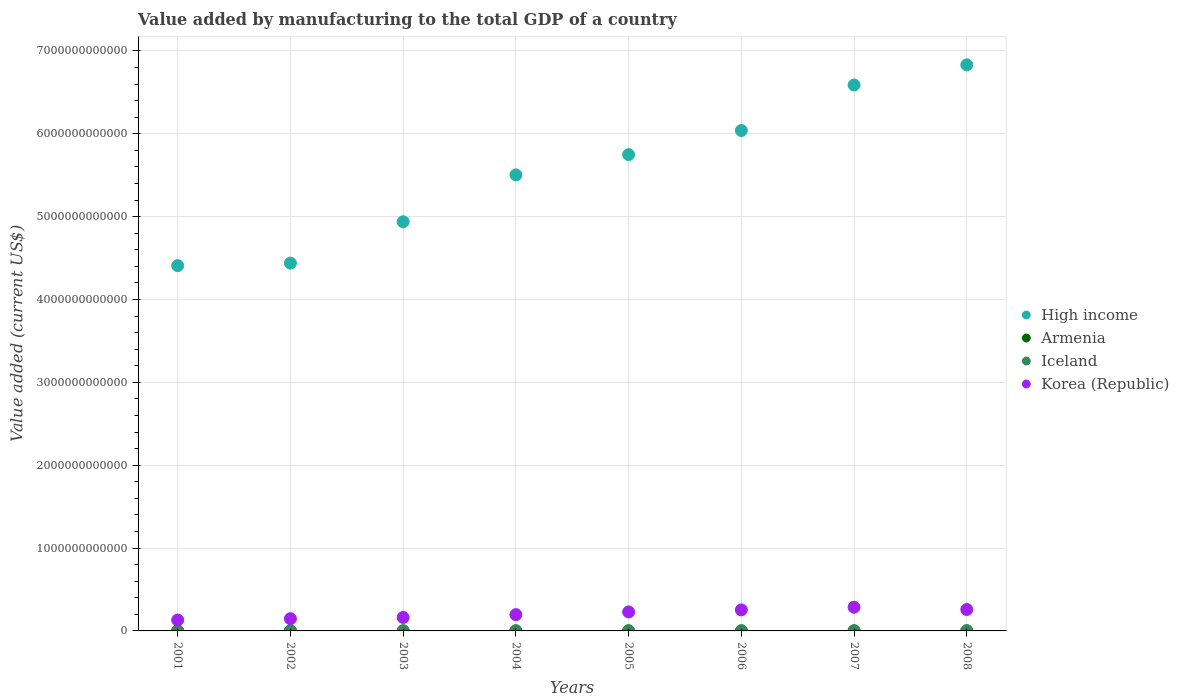How many different coloured dotlines are there?
Provide a succinct answer. 4. What is the value added by manufacturing to the total GDP in High income in 2005?
Provide a succinct answer. 5.75e+12. Across all years, what is the maximum value added by manufacturing to the total GDP in Iceland?
Offer a very short reply. 1.92e+09. Across all years, what is the minimum value added by manufacturing to the total GDP in Armenia?
Provide a succinct answer. 3.32e+08. In which year was the value added by manufacturing to the total GDP in High income maximum?
Offer a terse response. 2008. What is the total value added by manufacturing to the total GDP in High income in the graph?
Your answer should be compact. 4.45e+13. What is the difference between the value added by manufacturing to the total GDP in Armenia in 2004 and that in 2005?
Provide a short and direct response. -1.79e+08. What is the difference between the value added by manufacturing to the total GDP in Iceland in 2002 and the value added by manufacturing to the total GDP in Korea (Republic) in 2008?
Your response must be concise. -2.57e+11. What is the average value added by manufacturing to the total GDP in Korea (Republic) per year?
Provide a short and direct response. 2.08e+11. In the year 2008, what is the difference between the value added by manufacturing to the total GDP in Iceland and value added by manufacturing to the total GDP in Armenia?
Make the answer very short. 8.91e+08. What is the ratio of the value added by manufacturing to the total GDP in Iceland in 2003 to that in 2006?
Offer a very short reply. 0.8. Is the value added by manufacturing to the total GDP in Armenia in 2006 less than that in 2007?
Keep it short and to the point. Yes. Is the difference between the value added by manufacturing to the total GDP in Iceland in 2004 and 2008 greater than the difference between the value added by manufacturing to the total GDP in Armenia in 2004 and 2008?
Your answer should be compact. Yes. What is the difference between the highest and the second highest value added by manufacturing to the total GDP in Korea (Republic)?
Give a very brief answer. 2.73e+1. What is the difference between the highest and the lowest value added by manufacturing to the total GDP in Iceland?
Offer a very short reply. 8.62e+08. In how many years, is the value added by manufacturing to the total GDP in Armenia greater than the average value added by manufacturing to the total GDP in Armenia taken over all years?
Your answer should be compact. 4. Is the sum of the value added by manufacturing to the total GDP in Korea (Republic) in 2002 and 2006 greater than the maximum value added by manufacturing to the total GDP in Armenia across all years?
Your response must be concise. Yes. Is it the case that in every year, the sum of the value added by manufacturing to the total GDP in Armenia and value added by manufacturing to the total GDP in Korea (Republic)  is greater than the sum of value added by manufacturing to the total GDP in Iceland and value added by manufacturing to the total GDP in High income?
Give a very brief answer. Yes. Does the value added by manufacturing to the total GDP in Iceland monotonically increase over the years?
Ensure brevity in your answer.  No. What is the difference between two consecutive major ticks on the Y-axis?
Provide a short and direct response. 1.00e+12. Are the values on the major ticks of Y-axis written in scientific E-notation?
Provide a short and direct response. No. Does the graph contain grids?
Your answer should be compact. Yes. How are the legend labels stacked?
Your answer should be compact. Vertical. What is the title of the graph?
Provide a succinct answer. Value added by manufacturing to the total GDP of a country. What is the label or title of the Y-axis?
Give a very brief answer. Value added (current US$). What is the Value added (current US$) of High income in 2001?
Your answer should be very brief. 4.41e+12. What is the Value added (current US$) of Armenia in 2001?
Make the answer very short. 3.32e+08. What is the Value added (current US$) in Iceland in 2001?
Offer a very short reply. 1.08e+09. What is the Value added (current US$) in Korea (Republic) in 2001?
Your response must be concise. 1.31e+11. What is the Value added (current US$) in High income in 2002?
Your response must be concise. 4.44e+12. What is the Value added (current US$) of Armenia in 2002?
Give a very brief answer. 3.59e+08. What is the Value added (current US$) of Iceland in 2002?
Keep it short and to the point. 1.06e+09. What is the Value added (current US$) in Korea (Republic) in 2002?
Keep it short and to the point. 1.48e+11. What is the Value added (current US$) of High income in 2003?
Keep it short and to the point. 4.94e+12. What is the Value added (current US$) of Armenia in 2003?
Provide a succinct answer. 4.30e+08. What is the Value added (current US$) in Iceland in 2003?
Provide a succinct answer. 1.21e+09. What is the Value added (current US$) of Korea (Republic) in 2003?
Give a very brief answer. 1.62e+11. What is the Value added (current US$) of High income in 2004?
Provide a short and direct response. 5.50e+12. What is the Value added (current US$) of Armenia in 2004?
Offer a very short reply. 4.85e+08. What is the Value added (current US$) in Iceland in 2004?
Keep it short and to the point. 1.43e+09. What is the Value added (current US$) of Korea (Republic) in 2004?
Keep it short and to the point. 1.97e+11. What is the Value added (current US$) of High income in 2005?
Your response must be concise. 5.75e+12. What is the Value added (current US$) in Armenia in 2005?
Provide a short and direct response. 6.64e+08. What is the Value added (current US$) in Iceland in 2005?
Give a very brief answer. 1.48e+09. What is the Value added (current US$) of Korea (Republic) in 2005?
Your answer should be compact. 2.29e+11. What is the Value added (current US$) in High income in 2006?
Your answer should be compact. 6.04e+12. What is the Value added (current US$) in Armenia in 2006?
Your response must be concise. 6.93e+08. What is the Value added (current US$) in Iceland in 2006?
Ensure brevity in your answer.  1.51e+09. What is the Value added (current US$) in Korea (Republic) in 2006?
Provide a short and direct response. 2.54e+11. What is the Value added (current US$) in High income in 2007?
Provide a short and direct response. 6.59e+12. What is the Value added (current US$) in Armenia in 2007?
Your answer should be very brief. 8.63e+08. What is the Value added (current US$) of Iceland in 2007?
Make the answer very short. 1.64e+09. What is the Value added (current US$) in Korea (Republic) in 2007?
Your answer should be compact. 2.86e+11. What is the Value added (current US$) in High income in 2008?
Your answer should be very brief. 6.83e+12. What is the Value added (current US$) in Armenia in 2008?
Provide a succinct answer. 1.03e+09. What is the Value added (current US$) of Iceland in 2008?
Your response must be concise. 1.92e+09. What is the Value added (current US$) in Korea (Republic) in 2008?
Give a very brief answer. 2.59e+11. Across all years, what is the maximum Value added (current US$) of High income?
Your response must be concise. 6.83e+12. Across all years, what is the maximum Value added (current US$) of Armenia?
Give a very brief answer. 1.03e+09. Across all years, what is the maximum Value added (current US$) in Iceland?
Provide a short and direct response. 1.92e+09. Across all years, what is the maximum Value added (current US$) in Korea (Republic)?
Offer a very short reply. 2.86e+11. Across all years, what is the minimum Value added (current US$) of High income?
Provide a short and direct response. 4.41e+12. Across all years, what is the minimum Value added (current US$) in Armenia?
Your answer should be very brief. 3.32e+08. Across all years, what is the minimum Value added (current US$) of Iceland?
Your answer should be compact. 1.06e+09. Across all years, what is the minimum Value added (current US$) in Korea (Republic)?
Make the answer very short. 1.31e+11. What is the total Value added (current US$) of High income in the graph?
Offer a very short reply. 4.45e+13. What is the total Value added (current US$) of Armenia in the graph?
Ensure brevity in your answer.  4.86e+09. What is the total Value added (current US$) of Iceland in the graph?
Provide a short and direct response. 1.13e+1. What is the total Value added (current US$) in Korea (Republic) in the graph?
Your answer should be compact. 1.67e+12. What is the difference between the Value added (current US$) of High income in 2001 and that in 2002?
Your response must be concise. -3.11e+1. What is the difference between the Value added (current US$) of Armenia in 2001 and that in 2002?
Your answer should be compact. -2.71e+07. What is the difference between the Value added (current US$) in Iceland in 2001 and that in 2002?
Offer a terse response. 1.97e+07. What is the difference between the Value added (current US$) of Korea (Republic) in 2001 and that in 2002?
Provide a succinct answer. -1.61e+1. What is the difference between the Value added (current US$) of High income in 2001 and that in 2003?
Provide a short and direct response. -5.30e+11. What is the difference between the Value added (current US$) in Armenia in 2001 and that in 2003?
Make the answer very short. -9.76e+07. What is the difference between the Value added (current US$) in Iceland in 2001 and that in 2003?
Provide a succinct answer. -1.32e+08. What is the difference between the Value added (current US$) of Korea (Republic) in 2001 and that in 2003?
Make the answer very short. -3.09e+1. What is the difference between the Value added (current US$) of High income in 2001 and that in 2004?
Give a very brief answer. -1.10e+12. What is the difference between the Value added (current US$) of Armenia in 2001 and that in 2004?
Make the answer very short. -1.53e+08. What is the difference between the Value added (current US$) of Iceland in 2001 and that in 2004?
Give a very brief answer. -3.47e+08. What is the difference between the Value added (current US$) in Korea (Republic) in 2001 and that in 2004?
Your response must be concise. -6.53e+1. What is the difference between the Value added (current US$) of High income in 2001 and that in 2005?
Your response must be concise. -1.34e+12. What is the difference between the Value added (current US$) in Armenia in 2001 and that in 2005?
Make the answer very short. -3.32e+08. What is the difference between the Value added (current US$) of Iceland in 2001 and that in 2005?
Offer a very short reply. -4.02e+08. What is the difference between the Value added (current US$) in Korea (Republic) in 2001 and that in 2005?
Give a very brief answer. -9.77e+1. What is the difference between the Value added (current US$) of High income in 2001 and that in 2006?
Keep it short and to the point. -1.63e+12. What is the difference between the Value added (current US$) in Armenia in 2001 and that in 2006?
Make the answer very short. -3.60e+08. What is the difference between the Value added (current US$) of Iceland in 2001 and that in 2006?
Provide a succinct answer. -4.35e+08. What is the difference between the Value added (current US$) of Korea (Republic) in 2001 and that in 2006?
Your answer should be very brief. -1.22e+11. What is the difference between the Value added (current US$) in High income in 2001 and that in 2007?
Provide a short and direct response. -2.18e+12. What is the difference between the Value added (current US$) in Armenia in 2001 and that in 2007?
Provide a short and direct response. -5.31e+08. What is the difference between the Value added (current US$) in Iceland in 2001 and that in 2007?
Provide a succinct answer. -5.56e+08. What is the difference between the Value added (current US$) in Korea (Republic) in 2001 and that in 2007?
Keep it short and to the point. -1.54e+11. What is the difference between the Value added (current US$) of High income in 2001 and that in 2008?
Offer a terse response. -2.42e+12. What is the difference between the Value added (current US$) of Armenia in 2001 and that in 2008?
Make the answer very short. -6.99e+08. What is the difference between the Value added (current US$) in Iceland in 2001 and that in 2008?
Your response must be concise. -8.42e+08. What is the difference between the Value added (current US$) in Korea (Republic) in 2001 and that in 2008?
Give a very brief answer. -1.27e+11. What is the difference between the Value added (current US$) in High income in 2002 and that in 2003?
Provide a succinct answer. -4.99e+11. What is the difference between the Value added (current US$) in Armenia in 2002 and that in 2003?
Your answer should be compact. -7.05e+07. What is the difference between the Value added (current US$) of Iceland in 2002 and that in 2003?
Your answer should be very brief. -1.52e+08. What is the difference between the Value added (current US$) in Korea (Republic) in 2002 and that in 2003?
Provide a succinct answer. -1.49e+1. What is the difference between the Value added (current US$) in High income in 2002 and that in 2004?
Your response must be concise. -1.06e+12. What is the difference between the Value added (current US$) in Armenia in 2002 and that in 2004?
Provide a short and direct response. -1.26e+08. What is the difference between the Value added (current US$) of Iceland in 2002 and that in 2004?
Give a very brief answer. -3.66e+08. What is the difference between the Value added (current US$) of Korea (Republic) in 2002 and that in 2004?
Offer a very short reply. -4.92e+1. What is the difference between the Value added (current US$) in High income in 2002 and that in 2005?
Offer a very short reply. -1.31e+12. What is the difference between the Value added (current US$) in Armenia in 2002 and that in 2005?
Your answer should be compact. -3.05e+08. What is the difference between the Value added (current US$) of Iceland in 2002 and that in 2005?
Your answer should be very brief. -4.22e+08. What is the difference between the Value added (current US$) of Korea (Republic) in 2002 and that in 2005?
Provide a succinct answer. -8.16e+1. What is the difference between the Value added (current US$) of High income in 2002 and that in 2006?
Your answer should be very brief. -1.60e+12. What is the difference between the Value added (current US$) in Armenia in 2002 and that in 2006?
Your response must be concise. -3.33e+08. What is the difference between the Value added (current US$) in Iceland in 2002 and that in 2006?
Provide a succinct answer. -4.55e+08. What is the difference between the Value added (current US$) in Korea (Republic) in 2002 and that in 2006?
Your response must be concise. -1.06e+11. What is the difference between the Value added (current US$) of High income in 2002 and that in 2007?
Offer a terse response. -2.15e+12. What is the difference between the Value added (current US$) of Armenia in 2002 and that in 2007?
Your answer should be very brief. -5.03e+08. What is the difference between the Value added (current US$) of Iceland in 2002 and that in 2007?
Keep it short and to the point. -5.76e+08. What is the difference between the Value added (current US$) in Korea (Republic) in 2002 and that in 2007?
Your answer should be very brief. -1.38e+11. What is the difference between the Value added (current US$) of High income in 2002 and that in 2008?
Your response must be concise. -2.39e+12. What is the difference between the Value added (current US$) of Armenia in 2002 and that in 2008?
Give a very brief answer. -6.72e+08. What is the difference between the Value added (current US$) of Iceland in 2002 and that in 2008?
Your response must be concise. -8.62e+08. What is the difference between the Value added (current US$) of Korea (Republic) in 2002 and that in 2008?
Ensure brevity in your answer.  -1.11e+11. What is the difference between the Value added (current US$) in High income in 2003 and that in 2004?
Your response must be concise. -5.66e+11. What is the difference between the Value added (current US$) in Armenia in 2003 and that in 2004?
Your answer should be compact. -5.54e+07. What is the difference between the Value added (current US$) of Iceland in 2003 and that in 2004?
Make the answer very short. -2.15e+08. What is the difference between the Value added (current US$) of Korea (Republic) in 2003 and that in 2004?
Your answer should be compact. -3.43e+1. What is the difference between the Value added (current US$) of High income in 2003 and that in 2005?
Make the answer very short. -8.10e+11. What is the difference between the Value added (current US$) of Armenia in 2003 and that in 2005?
Your answer should be compact. -2.34e+08. What is the difference between the Value added (current US$) of Iceland in 2003 and that in 2005?
Your answer should be compact. -2.70e+08. What is the difference between the Value added (current US$) of Korea (Republic) in 2003 and that in 2005?
Offer a terse response. -6.67e+1. What is the difference between the Value added (current US$) of High income in 2003 and that in 2006?
Your answer should be compact. -1.10e+12. What is the difference between the Value added (current US$) in Armenia in 2003 and that in 2006?
Offer a very short reply. -2.63e+08. What is the difference between the Value added (current US$) of Iceland in 2003 and that in 2006?
Your answer should be very brief. -3.03e+08. What is the difference between the Value added (current US$) in Korea (Republic) in 2003 and that in 2006?
Your response must be concise. -9.13e+1. What is the difference between the Value added (current US$) of High income in 2003 and that in 2007?
Make the answer very short. -1.65e+12. What is the difference between the Value added (current US$) of Armenia in 2003 and that in 2007?
Offer a very short reply. -4.33e+08. What is the difference between the Value added (current US$) of Iceland in 2003 and that in 2007?
Keep it short and to the point. -4.24e+08. What is the difference between the Value added (current US$) in Korea (Republic) in 2003 and that in 2007?
Provide a succinct answer. -1.23e+11. What is the difference between the Value added (current US$) of High income in 2003 and that in 2008?
Keep it short and to the point. -1.89e+12. What is the difference between the Value added (current US$) of Armenia in 2003 and that in 2008?
Give a very brief answer. -6.01e+08. What is the difference between the Value added (current US$) of Iceland in 2003 and that in 2008?
Offer a terse response. -7.10e+08. What is the difference between the Value added (current US$) of Korea (Republic) in 2003 and that in 2008?
Provide a short and direct response. -9.61e+1. What is the difference between the Value added (current US$) in High income in 2004 and that in 2005?
Offer a very short reply. -2.44e+11. What is the difference between the Value added (current US$) of Armenia in 2004 and that in 2005?
Keep it short and to the point. -1.79e+08. What is the difference between the Value added (current US$) in Iceland in 2004 and that in 2005?
Your answer should be compact. -5.56e+07. What is the difference between the Value added (current US$) of Korea (Republic) in 2004 and that in 2005?
Make the answer very short. -3.24e+1. What is the difference between the Value added (current US$) in High income in 2004 and that in 2006?
Offer a very short reply. -5.35e+11. What is the difference between the Value added (current US$) in Armenia in 2004 and that in 2006?
Keep it short and to the point. -2.07e+08. What is the difference between the Value added (current US$) in Iceland in 2004 and that in 2006?
Your response must be concise. -8.86e+07. What is the difference between the Value added (current US$) of Korea (Republic) in 2004 and that in 2006?
Keep it short and to the point. -5.70e+1. What is the difference between the Value added (current US$) of High income in 2004 and that in 2007?
Provide a short and direct response. -1.08e+12. What is the difference between the Value added (current US$) in Armenia in 2004 and that in 2007?
Your response must be concise. -3.78e+08. What is the difference between the Value added (current US$) of Iceland in 2004 and that in 2007?
Your answer should be very brief. -2.09e+08. What is the difference between the Value added (current US$) of Korea (Republic) in 2004 and that in 2007?
Offer a very short reply. -8.91e+1. What is the difference between the Value added (current US$) of High income in 2004 and that in 2008?
Provide a succinct answer. -1.33e+12. What is the difference between the Value added (current US$) in Armenia in 2004 and that in 2008?
Ensure brevity in your answer.  -5.46e+08. What is the difference between the Value added (current US$) of Iceland in 2004 and that in 2008?
Your answer should be very brief. -4.96e+08. What is the difference between the Value added (current US$) of Korea (Republic) in 2004 and that in 2008?
Offer a terse response. -6.18e+1. What is the difference between the Value added (current US$) of High income in 2005 and that in 2006?
Your answer should be very brief. -2.91e+11. What is the difference between the Value added (current US$) in Armenia in 2005 and that in 2006?
Provide a short and direct response. -2.88e+07. What is the difference between the Value added (current US$) of Iceland in 2005 and that in 2006?
Your answer should be compact. -3.30e+07. What is the difference between the Value added (current US$) in Korea (Republic) in 2005 and that in 2006?
Your answer should be very brief. -2.46e+1. What is the difference between the Value added (current US$) in High income in 2005 and that in 2007?
Provide a succinct answer. -8.40e+11. What is the difference between the Value added (current US$) of Armenia in 2005 and that in 2007?
Your answer should be very brief. -1.99e+08. What is the difference between the Value added (current US$) in Iceland in 2005 and that in 2007?
Provide a short and direct response. -1.54e+08. What is the difference between the Value added (current US$) in Korea (Republic) in 2005 and that in 2007?
Offer a very short reply. -5.67e+1. What is the difference between the Value added (current US$) of High income in 2005 and that in 2008?
Give a very brief answer. -1.08e+12. What is the difference between the Value added (current US$) in Armenia in 2005 and that in 2008?
Provide a succinct answer. -3.67e+08. What is the difference between the Value added (current US$) of Iceland in 2005 and that in 2008?
Provide a succinct answer. -4.40e+08. What is the difference between the Value added (current US$) of Korea (Republic) in 2005 and that in 2008?
Offer a terse response. -2.94e+1. What is the difference between the Value added (current US$) in High income in 2006 and that in 2007?
Provide a succinct answer. -5.49e+11. What is the difference between the Value added (current US$) in Armenia in 2006 and that in 2007?
Make the answer very short. -1.70e+08. What is the difference between the Value added (current US$) in Iceland in 2006 and that in 2007?
Your answer should be very brief. -1.21e+08. What is the difference between the Value added (current US$) in Korea (Republic) in 2006 and that in 2007?
Provide a succinct answer. -3.21e+1. What is the difference between the Value added (current US$) of High income in 2006 and that in 2008?
Provide a short and direct response. -7.92e+11. What is the difference between the Value added (current US$) of Armenia in 2006 and that in 2008?
Offer a terse response. -3.39e+08. What is the difference between the Value added (current US$) of Iceland in 2006 and that in 2008?
Your answer should be very brief. -4.07e+08. What is the difference between the Value added (current US$) of Korea (Republic) in 2006 and that in 2008?
Offer a terse response. -4.79e+09. What is the difference between the Value added (current US$) of High income in 2007 and that in 2008?
Make the answer very short. -2.43e+11. What is the difference between the Value added (current US$) in Armenia in 2007 and that in 2008?
Your response must be concise. -1.68e+08. What is the difference between the Value added (current US$) in Iceland in 2007 and that in 2008?
Give a very brief answer. -2.86e+08. What is the difference between the Value added (current US$) of Korea (Republic) in 2007 and that in 2008?
Your answer should be very brief. 2.73e+1. What is the difference between the Value added (current US$) in High income in 2001 and the Value added (current US$) in Armenia in 2002?
Provide a short and direct response. 4.41e+12. What is the difference between the Value added (current US$) in High income in 2001 and the Value added (current US$) in Iceland in 2002?
Provide a succinct answer. 4.41e+12. What is the difference between the Value added (current US$) in High income in 2001 and the Value added (current US$) in Korea (Republic) in 2002?
Provide a short and direct response. 4.26e+12. What is the difference between the Value added (current US$) in Armenia in 2001 and the Value added (current US$) in Iceland in 2002?
Ensure brevity in your answer.  -7.28e+08. What is the difference between the Value added (current US$) of Armenia in 2001 and the Value added (current US$) of Korea (Republic) in 2002?
Your answer should be very brief. -1.47e+11. What is the difference between the Value added (current US$) of Iceland in 2001 and the Value added (current US$) of Korea (Republic) in 2002?
Your answer should be very brief. -1.46e+11. What is the difference between the Value added (current US$) in High income in 2001 and the Value added (current US$) in Armenia in 2003?
Provide a short and direct response. 4.41e+12. What is the difference between the Value added (current US$) of High income in 2001 and the Value added (current US$) of Iceland in 2003?
Your response must be concise. 4.41e+12. What is the difference between the Value added (current US$) in High income in 2001 and the Value added (current US$) in Korea (Republic) in 2003?
Provide a succinct answer. 4.25e+12. What is the difference between the Value added (current US$) in Armenia in 2001 and the Value added (current US$) in Iceland in 2003?
Give a very brief answer. -8.79e+08. What is the difference between the Value added (current US$) in Armenia in 2001 and the Value added (current US$) in Korea (Republic) in 2003?
Offer a terse response. -1.62e+11. What is the difference between the Value added (current US$) in Iceland in 2001 and the Value added (current US$) in Korea (Republic) in 2003?
Provide a short and direct response. -1.61e+11. What is the difference between the Value added (current US$) of High income in 2001 and the Value added (current US$) of Armenia in 2004?
Give a very brief answer. 4.41e+12. What is the difference between the Value added (current US$) in High income in 2001 and the Value added (current US$) in Iceland in 2004?
Your answer should be compact. 4.41e+12. What is the difference between the Value added (current US$) of High income in 2001 and the Value added (current US$) of Korea (Republic) in 2004?
Offer a terse response. 4.21e+12. What is the difference between the Value added (current US$) in Armenia in 2001 and the Value added (current US$) in Iceland in 2004?
Keep it short and to the point. -1.09e+09. What is the difference between the Value added (current US$) of Armenia in 2001 and the Value added (current US$) of Korea (Republic) in 2004?
Provide a short and direct response. -1.96e+11. What is the difference between the Value added (current US$) in Iceland in 2001 and the Value added (current US$) in Korea (Republic) in 2004?
Provide a succinct answer. -1.96e+11. What is the difference between the Value added (current US$) of High income in 2001 and the Value added (current US$) of Armenia in 2005?
Provide a succinct answer. 4.41e+12. What is the difference between the Value added (current US$) of High income in 2001 and the Value added (current US$) of Iceland in 2005?
Make the answer very short. 4.41e+12. What is the difference between the Value added (current US$) in High income in 2001 and the Value added (current US$) in Korea (Republic) in 2005?
Your response must be concise. 4.18e+12. What is the difference between the Value added (current US$) of Armenia in 2001 and the Value added (current US$) of Iceland in 2005?
Offer a very short reply. -1.15e+09. What is the difference between the Value added (current US$) of Armenia in 2001 and the Value added (current US$) of Korea (Republic) in 2005?
Make the answer very short. -2.29e+11. What is the difference between the Value added (current US$) in Iceland in 2001 and the Value added (current US$) in Korea (Republic) in 2005?
Your response must be concise. -2.28e+11. What is the difference between the Value added (current US$) in High income in 2001 and the Value added (current US$) in Armenia in 2006?
Keep it short and to the point. 4.41e+12. What is the difference between the Value added (current US$) in High income in 2001 and the Value added (current US$) in Iceland in 2006?
Keep it short and to the point. 4.41e+12. What is the difference between the Value added (current US$) of High income in 2001 and the Value added (current US$) of Korea (Republic) in 2006?
Make the answer very short. 4.15e+12. What is the difference between the Value added (current US$) of Armenia in 2001 and the Value added (current US$) of Iceland in 2006?
Your response must be concise. -1.18e+09. What is the difference between the Value added (current US$) in Armenia in 2001 and the Value added (current US$) in Korea (Republic) in 2006?
Make the answer very short. -2.53e+11. What is the difference between the Value added (current US$) of Iceland in 2001 and the Value added (current US$) of Korea (Republic) in 2006?
Your answer should be compact. -2.53e+11. What is the difference between the Value added (current US$) of High income in 2001 and the Value added (current US$) of Armenia in 2007?
Provide a short and direct response. 4.41e+12. What is the difference between the Value added (current US$) in High income in 2001 and the Value added (current US$) in Iceland in 2007?
Your response must be concise. 4.41e+12. What is the difference between the Value added (current US$) in High income in 2001 and the Value added (current US$) in Korea (Republic) in 2007?
Ensure brevity in your answer.  4.12e+12. What is the difference between the Value added (current US$) in Armenia in 2001 and the Value added (current US$) in Iceland in 2007?
Keep it short and to the point. -1.30e+09. What is the difference between the Value added (current US$) of Armenia in 2001 and the Value added (current US$) of Korea (Republic) in 2007?
Offer a very short reply. -2.86e+11. What is the difference between the Value added (current US$) in Iceland in 2001 and the Value added (current US$) in Korea (Republic) in 2007?
Give a very brief answer. -2.85e+11. What is the difference between the Value added (current US$) in High income in 2001 and the Value added (current US$) in Armenia in 2008?
Keep it short and to the point. 4.41e+12. What is the difference between the Value added (current US$) of High income in 2001 and the Value added (current US$) of Iceland in 2008?
Your answer should be compact. 4.41e+12. What is the difference between the Value added (current US$) of High income in 2001 and the Value added (current US$) of Korea (Republic) in 2008?
Your response must be concise. 4.15e+12. What is the difference between the Value added (current US$) of Armenia in 2001 and the Value added (current US$) of Iceland in 2008?
Ensure brevity in your answer.  -1.59e+09. What is the difference between the Value added (current US$) in Armenia in 2001 and the Value added (current US$) in Korea (Republic) in 2008?
Offer a very short reply. -2.58e+11. What is the difference between the Value added (current US$) of Iceland in 2001 and the Value added (current US$) of Korea (Republic) in 2008?
Provide a short and direct response. -2.57e+11. What is the difference between the Value added (current US$) in High income in 2002 and the Value added (current US$) in Armenia in 2003?
Offer a very short reply. 4.44e+12. What is the difference between the Value added (current US$) of High income in 2002 and the Value added (current US$) of Iceland in 2003?
Keep it short and to the point. 4.44e+12. What is the difference between the Value added (current US$) of High income in 2002 and the Value added (current US$) of Korea (Republic) in 2003?
Offer a terse response. 4.28e+12. What is the difference between the Value added (current US$) in Armenia in 2002 and the Value added (current US$) in Iceland in 2003?
Offer a very short reply. -8.52e+08. What is the difference between the Value added (current US$) of Armenia in 2002 and the Value added (current US$) of Korea (Republic) in 2003?
Keep it short and to the point. -1.62e+11. What is the difference between the Value added (current US$) of Iceland in 2002 and the Value added (current US$) of Korea (Republic) in 2003?
Give a very brief answer. -1.61e+11. What is the difference between the Value added (current US$) of High income in 2002 and the Value added (current US$) of Armenia in 2004?
Ensure brevity in your answer.  4.44e+12. What is the difference between the Value added (current US$) of High income in 2002 and the Value added (current US$) of Iceland in 2004?
Keep it short and to the point. 4.44e+12. What is the difference between the Value added (current US$) in High income in 2002 and the Value added (current US$) in Korea (Republic) in 2004?
Give a very brief answer. 4.24e+12. What is the difference between the Value added (current US$) in Armenia in 2002 and the Value added (current US$) in Iceland in 2004?
Your answer should be compact. -1.07e+09. What is the difference between the Value added (current US$) of Armenia in 2002 and the Value added (current US$) of Korea (Republic) in 2004?
Your answer should be very brief. -1.96e+11. What is the difference between the Value added (current US$) of Iceland in 2002 and the Value added (current US$) of Korea (Republic) in 2004?
Make the answer very short. -1.96e+11. What is the difference between the Value added (current US$) in High income in 2002 and the Value added (current US$) in Armenia in 2005?
Offer a terse response. 4.44e+12. What is the difference between the Value added (current US$) in High income in 2002 and the Value added (current US$) in Iceland in 2005?
Offer a terse response. 4.44e+12. What is the difference between the Value added (current US$) of High income in 2002 and the Value added (current US$) of Korea (Republic) in 2005?
Your answer should be very brief. 4.21e+12. What is the difference between the Value added (current US$) of Armenia in 2002 and the Value added (current US$) of Iceland in 2005?
Your response must be concise. -1.12e+09. What is the difference between the Value added (current US$) in Armenia in 2002 and the Value added (current US$) in Korea (Republic) in 2005?
Provide a short and direct response. -2.29e+11. What is the difference between the Value added (current US$) in Iceland in 2002 and the Value added (current US$) in Korea (Republic) in 2005?
Provide a succinct answer. -2.28e+11. What is the difference between the Value added (current US$) in High income in 2002 and the Value added (current US$) in Armenia in 2006?
Your answer should be very brief. 4.44e+12. What is the difference between the Value added (current US$) of High income in 2002 and the Value added (current US$) of Iceland in 2006?
Offer a terse response. 4.44e+12. What is the difference between the Value added (current US$) in High income in 2002 and the Value added (current US$) in Korea (Republic) in 2006?
Make the answer very short. 4.19e+12. What is the difference between the Value added (current US$) of Armenia in 2002 and the Value added (current US$) of Iceland in 2006?
Ensure brevity in your answer.  -1.16e+09. What is the difference between the Value added (current US$) in Armenia in 2002 and the Value added (current US$) in Korea (Republic) in 2006?
Ensure brevity in your answer.  -2.53e+11. What is the difference between the Value added (current US$) in Iceland in 2002 and the Value added (current US$) in Korea (Republic) in 2006?
Offer a terse response. -2.53e+11. What is the difference between the Value added (current US$) of High income in 2002 and the Value added (current US$) of Armenia in 2007?
Give a very brief answer. 4.44e+12. What is the difference between the Value added (current US$) of High income in 2002 and the Value added (current US$) of Iceland in 2007?
Offer a very short reply. 4.44e+12. What is the difference between the Value added (current US$) of High income in 2002 and the Value added (current US$) of Korea (Republic) in 2007?
Offer a terse response. 4.15e+12. What is the difference between the Value added (current US$) in Armenia in 2002 and the Value added (current US$) in Iceland in 2007?
Offer a terse response. -1.28e+09. What is the difference between the Value added (current US$) of Armenia in 2002 and the Value added (current US$) of Korea (Republic) in 2007?
Ensure brevity in your answer.  -2.85e+11. What is the difference between the Value added (current US$) in Iceland in 2002 and the Value added (current US$) in Korea (Republic) in 2007?
Ensure brevity in your answer.  -2.85e+11. What is the difference between the Value added (current US$) of High income in 2002 and the Value added (current US$) of Armenia in 2008?
Give a very brief answer. 4.44e+12. What is the difference between the Value added (current US$) in High income in 2002 and the Value added (current US$) in Iceland in 2008?
Provide a short and direct response. 4.44e+12. What is the difference between the Value added (current US$) in High income in 2002 and the Value added (current US$) in Korea (Republic) in 2008?
Provide a short and direct response. 4.18e+12. What is the difference between the Value added (current US$) of Armenia in 2002 and the Value added (current US$) of Iceland in 2008?
Offer a very short reply. -1.56e+09. What is the difference between the Value added (current US$) of Armenia in 2002 and the Value added (current US$) of Korea (Republic) in 2008?
Provide a short and direct response. -2.58e+11. What is the difference between the Value added (current US$) in Iceland in 2002 and the Value added (current US$) in Korea (Republic) in 2008?
Offer a terse response. -2.57e+11. What is the difference between the Value added (current US$) of High income in 2003 and the Value added (current US$) of Armenia in 2004?
Give a very brief answer. 4.94e+12. What is the difference between the Value added (current US$) in High income in 2003 and the Value added (current US$) in Iceland in 2004?
Make the answer very short. 4.94e+12. What is the difference between the Value added (current US$) in High income in 2003 and the Value added (current US$) in Korea (Republic) in 2004?
Ensure brevity in your answer.  4.74e+12. What is the difference between the Value added (current US$) of Armenia in 2003 and the Value added (current US$) of Iceland in 2004?
Give a very brief answer. -9.96e+08. What is the difference between the Value added (current US$) of Armenia in 2003 and the Value added (current US$) of Korea (Republic) in 2004?
Your response must be concise. -1.96e+11. What is the difference between the Value added (current US$) of Iceland in 2003 and the Value added (current US$) of Korea (Republic) in 2004?
Provide a short and direct response. -1.96e+11. What is the difference between the Value added (current US$) of High income in 2003 and the Value added (current US$) of Armenia in 2005?
Provide a succinct answer. 4.94e+12. What is the difference between the Value added (current US$) of High income in 2003 and the Value added (current US$) of Iceland in 2005?
Give a very brief answer. 4.94e+12. What is the difference between the Value added (current US$) in High income in 2003 and the Value added (current US$) in Korea (Republic) in 2005?
Offer a terse response. 4.71e+12. What is the difference between the Value added (current US$) of Armenia in 2003 and the Value added (current US$) of Iceland in 2005?
Your answer should be very brief. -1.05e+09. What is the difference between the Value added (current US$) of Armenia in 2003 and the Value added (current US$) of Korea (Republic) in 2005?
Your response must be concise. -2.29e+11. What is the difference between the Value added (current US$) in Iceland in 2003 and the Value added (current US$) in Korea (Republic) in 2005?
Offer a terse response. -2.28e+11. What is the difference between the Value added (current US$) of High income in 2003 and the Value added (current US$) of Armenia in 2006?
Make the answer very short. 4.94e+12. What is the difference between the Value added (current US$) in High income in 2003 and the Value added (current US$) in Iceland in 2006?
Offer a very short reply. 4.94e+12. What is the difference between the Value added (current US$) in High income in 2003 and the Value added (current US$) in Korea (Republic) in 2006?
Make the answer very short. 4.68e+12. What is the difference between the Value added (current US$) of Armenia in 2003 and the Value added (current US$) of Iceland in 2006?
Give a very brief answer. -1.09e+09. What is the difference between the Value added (current US$) in Armenia in 2003 and the Value added (current US$) in Korea (Republic) in 2006?
Provide a succinct answer. -2.53e+11. What is the difference between the Value added (current US$) of Iceland in 2003 and the Value added (current US$) of Korea (Republic) in 2006?
Keep it short and to the point. -2.53e+11. What is the difference between the Value added (current US$) in High income in 2003 and the Value added (current US$) in Armenia in 2007?
Your response must be concise. 4.94e+12. What is the difference between the Value added (current US$) in High income in 2003 and the Value added (current US$) in Iceland in 2007?
Your answer should be compact. 4.94e+12. What is the difference between the Value added (current US$) of High income in 2003 and the Value added (current US$) of Korea (Republic) in 2007?
Offer a very short reply. 4.65e+12. What is the difference between the Value added (current US$) in Armenia in 2003 and the Value added (current US$) in Iceland in 2007?
Your response must be concise. -1.21e+09. What is the difference between the Value added (current US$) in Armenia in 2003 and the Value added (current US$) in Korea (Republic) in 2007?
Keep it short and to the point. -2.85e+11. What is the difference between the Value added (current US$) in Iceland in 2003 and the Value added (current US$) in Korea (Republic) in 2007?
Your answer should be very brief. -2.85e+11. What is the difference between the Value added (current US$) of High income in 2003 and the Value added (current US$) of Armenia in 2008?
Give a very brief answer. 4.94e+12. What is the difference between the Value added (current US$) of High income in 2003 and the Value added (current US$) of Iceland in 2008?
Keep it short and to the point. 4.94e+12. What is the difference between the Value added (current US$) of High income in 2003 and the Value added (current US$) of Korea (Republic) in 2008?
Your response must be concise. 4.68e+12. What is the difference between the Value added (current US$) of Armenia in 2003 and the Value added (current US$) of Iceland in 2008?
Ensure brevity in your answer.  -1.49e+09. What is the difference between the Value added (current US$) of Armenia in 2003 and the Value added (current US$) of Korea (Republic) in 2008?
Your answer should be compact. -2.58e+11. What is the difference between the Value added (current US$) in Iceland in 2003 and the Value added (current US$) in Korea (Republic) in 2008?
Offer a terse response. -2.57e+11. What is the difference between the Value added (current US$) in High income in 2004 and the Value added (current US$) in Armenia in 2005?
Your response must be concise. 5.50e+12. What is the difference between the Value added (current US$) in High income in 2004 and the Value added (current US$) in Iceland in 2005?
Keep it short and to the point. 5.50e+12. What is the difference between the Value added (current US$) in High income in 2004 and the Value added (current US$) in Korea (Republic) in 2005?
Offer a very short reply. 5.27e+12. What is the difference between the Value added (current US$) of Armenia in 2004 and the Value added (current US$) of Iceland in 2005?
Your response must be concise. -9.97e+08. What is the difference between the Value added (current US$) of Armenia in 2004 and the Value added (current US$) of Korea (Republic) in 2005?
Provide a succinct answer. -2.29e+11. What is the difference between the Value added (current US$) in Iceland in 2004 and the Value added (current US$) in Korea (Republic) in 2005?
Give a very brief answer. -2.28e+11. What is the difference between the Value added (current US$) of High income in 2004 and the Value added (current US$) of Armenia in 2006?
Provide a short and direct response. 5.50e+12. What is the difference between the Value added (current US$) of High income in 2004 and the Value added (current US$) of Iceland in 2006?
Ensure brevity in your answer.  5.50e+12. What is the difference between the Value added (current US$) in High income in 2004 and the Value added (current US$) in Korea (Republic) in 2006?
Provide a short and direct response. 5.25e+12. What is the difference between the Value added (current US$) of Armenia in 2004 and the Value added (current US$) of Iceland in 2006?
Ensure brevity in your answer.  -1.03e+09. What is the difference between the Value added (current US$) of Armenia in 2004 and the Value added (current US$) of Korea (Republic) in 2006?
Keep it short and to the point. -2.53e+11. What is the difference between the Value added (current US$) of Iceland in 2004 and the Value added (current US$) of Korea (Republic) in 2006?
Offer a terse response. -2.52e+11. What is the difference between the Value added (current US$) in High income in 2004 and the Value added (current US$) in Armenia in 2007?
Ensure brevity in your answer.  5.50e+12. What is the difference between the Value added (current US$) of High income in 2004 and the Value added (current US$) of Iceland in 2007?
Ensure brevity in your answer.  5.50e+12. What is the difference between the Value added (current US$) of High income in 2004 and the Value added (current US$) of Korea (Republic) in 2007?
Keep it short and to the point. 5.22e+12. What is the difference between the Value added (current US$) in Armenia in 2004 and the Value added (current US$) in Iceland in 2007?
Your response must be concise. -1.15e+09. What is the difference between the Value added (current US$) in Armenia in 2004 and the Value added (current US$) in Korea (Republic) in 2007?
Provide a succinct answer. -2.85e+11. What is the difference between the Value added (current US$) of Iceland in 2004 and the Value added (current US$) of Korea (Republic) in 2007?
Offer a terse response. -2.84e+11. What is the difference between the Value added (current US$) in High income in 2004 and the Value added (current US$) in Armenia in 2008?
Provide a succinct answer. 5.50e+12. What is the difference between the Value added (current US$) in High income in 2004 and the Value added (current US$) in Iceland in 2008?
Offer a terse response. 5.50e+12. What is the difference between the Value added (current US$) of High income in 2004 and the Value added (current US$) of Korea (Republic) in 2008?
Give a very brief answer. 5.25e+12. What is the difference between the Value added (current US$) in Armenia in 2004 and the Value added (current US$) in Iceland in 2008?
Offer a very short reply. -1.44e+09. What is the difference between the Value added (current US$) in Armenia in 2004 and the Value added (current US$) in Korea (Republic) in 2008?
Your answer should be compact. -2.58e+11. What is the difference between the Value added (current US$) of Iceland in 2004 and the Value added (current US$) of Korea (Republic) in 2008?
Your response must be concise. -2.57e+11. What is the difference between the Value added (current US$) in High income in 2005 and the Value added (current US$) in Armenia in 2006?
Your response must be concise. 5.75e+12. What is the difference between the Value added (current US$) of High income in 2005 and the Value added (current US$) of Iceland in 2006?
Provide a succinct answer. 5.75e+12. What is the difference between the Value added (current US$) in High income in 2005 and the Value added (current US$) in Korea (Republic) in 2006?
Your answer should be compact. 5.49e+12. What is the difference between the Value added (current US$) in Armenia in 2005 and the Value added (current US$) in Iceland in 2006?
Provide a short and direct response. -8.51e+08. What is the difference between the Value added (current US$) of Armenia in 2005 and the Value added (current US$) of Korea (Republic) in 2006?
Offer a terse response. -2.53e+11. What is the difference between the Value added (current US$) of Iceland in 2005 and the Value added (current US$) of Korea (Republic) in 2006?
Your answer should be compact. -2.52e+11. What is the difference between the Value added (current US$) in High income in 2005 and the Value added (current US$) in Armenia in 2007?
Offer a very short reply. 5.75e+12. What is the difference between the Value added (current US$) in High income in 2005 and the Value added (current US$) in Iceland in 2007?
Offer a very short reply. 5.75e+12. What is the difference between the Value added (current US$) in High income in 2005 and the Value added (current US$) in Korea (Republic) in 2007?
Provide a short and direct response. 5.46e+12. What is the difference between the Value added (current US$) in Armenia in 2005 and the Value added (current US$) in Iceland in 2007?
Offer a terse response. -9.72e+08. What is the difference between the Value added (current US$) of Armenia in 2005 and the Value added (current US$) of Korea (Republic) in 2007?
Your answer should be very brief. -2.85e+11. What is the difference between the Value added (current US$) of Iceland in 2005 and the Value added (current US$) of Korea (Republic) in 2007?
Give a very brief answer. -2.84e+11. What is the difference between the Value added (current US$) of High income in 2005 and the Value added (current US$) of Armenia in 2008?
Offer a terse response. 5.75e+12. What is the difference between the Value added (current US$) in High income in 2005 and the Value added (current US$) in Iceland in 2008?
Give a very brief answer. 5.75e+12. What is the difference between the Value added (current US$) in High income in 2005 and the Value added (current US$) in Korea (Republic) in 2008?
Provide a succinct answer. 5.49e+12. What is the difference between the Value added (current US$) in Armenia in 2005 and the Value added (current US$) in Iceland in 2008?
Your response must be concise. -1.26e+09. What is the difference between the Value added (current US$) in Armenia in 2005 and the Value added (current US$) in Korea (Republic) in 2008?
Offer a terse response. -2.58e+11. What is the difference between the Value added (current US$) in Iceland in 2005 and the Value added (current US$) in Korea (Republic) in 2008?
Give a very brief answer. -2.57e+11. What is the difference between the Value added (current US$) of High income in 2006 and the Value added (current US$) of Armenia in 2007?
Provide a short and direct response. 6.04e+12. What is the difference between the Value added (current US$) of High income in 2006 and the Value added (current US$) of Iceland in 2007?
Your response must be concise. 6.04e+12. What is the difference between the Value added (current US$) in High income in 2006 and the Value added (current US$) in Korea (Republic) in 2007?
Provide a short and direct response. 5.75e+12. What is the difference between the Value added (current US$) of Armenia in 2006 and the Value added (current US$) of Iceland in 2007?
Your response must be concise. -9.43e+08. What is the difference between the Value added (current US$) in Armenia in 2006 and the Value added (current US$) in Korea (Republic) in 2007?
Ensure brevity in your answer.  -2.85e+11. What is the difference between the Value added (current US$) in Iceland in 2006 and the Value added (current US$) in Korea (Republic) in 2007?
Give a very brief answer. -2.84e+11. What is the difference between the Value added (current US$) of High income in 2006 and the Value added (current US$) of Armenia in 2008?
Keep it short and to the point. 6.04e+12. What is the difference between the Value added (current US$) of High income in 2006 and the Value added (current US$) of Iceland in 2008?
Give a very brief answer. 6.04e+12. What is the difference between the Value added (current US$) in High income in 2006 and the Value added (current US$) in Korea (Republic) in 2008?
Keep it short and to the point. 5.78e+12. What is the difference between the Value added (current US$) of Armenia in 2006 and the Value added (current US$) of Iceland in 2008?
Your response must be concise. -1.23e+09. What is the difference between the Value added (current US$) in Armenia in 2006 and the Value added (current US$) in Korea (Republic) in 2008?
Make the answer very short. -2.58e+11. What is the difference between the Value added (current US$) of Iceland in 2006 and the Value added (current US$) of Korea (Republic) in 2008?
Provide a succinct answer. -2.57e+11. What is the difference between the Value added (current US$) of High income in 2007 and the Value added (current US$) of Armenia in 2008?
Offer a very short reply. 6.59e+12. What is the difference between the Value added (current US$) in High income in 2007 and the Value added (current US$) in Iceland in 2008?
Provide a succinct answer. 6.59e+12. What is the difference between the Value added (current US$) of High income in 2007 and the Value added (current US$) of Korea (Republic) in 2008?
Your answer should be compact. 6.33e+12. What is the difference between the Value added (current US$) in Armenia in 2007 and the Value added (current US$) in Iceland in 2008?
Offer a very short reply. -1.06e+09. What is the difference between the Value added (current US$) of Armenia in 2007 and the Value added (current US$) of Korea (Republic) in 2008?
Provide a short and direct response. -2.58e+11. What is the difference between the Value added (current US$) of Iceland in 2007 and the Value added (current US$) of Korea (Republic) in 2008?
Provide a short and direct response. -2.57e+11. What is the average Value added (current US$) in High income per year?
Give a very brief answer. 5.56e+12. What is the average Value added (current US$) of Armenia per year?
Give a very brief answer. 6.07e+08. What is the average Value added (current US$) in Iceland per year?
Your response must be concise. 1.42e+09. What is the average Value added (current US$) of Korea (Republic) per year?
Keep it short and to the point. 2.08e+11. In the year 2001, what is the difference between the Value added (current US$) of High income and Value added (current US$) of Armenia?
Keep it short and to the point. 4.41e+12. In the year 2001, what is the difference between the Value added (current US$) of High income and Value added (current US$) of Iceland?
Your response must be concise. 4.41e+12. In the year 2001, what is the difference between the Value added (current US$) in High income and Value added (current US$) in Korea (Republic)?
Your answer should be very brief. 4.28e+12. In the year 2001, what is the difference between the Value added (current US$) in Armenia and Value added (current US$) in Iceland?
Provide a short and direct response. -7.47e+08. In the year 2001, what is the difference between the Value added (current US$) of Armenia and Value added (current US$) of Korea (Republic)?
Offer a terse response. -1.31e+11. In the year 2001, what is the difference between the Value added (current US$) of Iceland and Value added (current US$) of Korea (Republic)?
Your answer should be compact. -1.30e+11. In the year 2002, what is the difference between the Value added (current US$) in High income and Value added (current US$) in Armenia?
Provide a short and direct response. 4.44e+12. In the year 2002, what is the difference between the Value added (current US$) in High income and Value added (current US$) in Iceland?
Provide a short and direct response. 4.44e+12. In the year 2002, what is the difference between the Value added (current US$) of High income and Value added (current US$) of Korea (Republic)?
Your answer should be very brief. 4.29e+12. In the year 2002, what is the difference between the Value added (current US$) of Armenia and Value added (current US$) of Iceland?
Your answer should be very brief. -7.00e+08. In the year 2002, what is the difference between the Value added (current US$) in Armenia and Value added (current US$) in Korea (Republic)?
Keep it short and to the point. -1.47e+11. In the year 2002, what is the difference between the Value added (current US$) in Iceland and Value added (current US$) in Korea (Republic)?
Make the answer very short. -1.46e+11. In the year 2003, what is the difference between the Value added (current US$) of High income and Value added (current US$) of Armenia?
Provide a short and direct response. 4.94e+12. In the year 2003, what is the difference between the Value added (current US$) in High income and Value added (current US$) in Iceland?
Keep it short and to the point. 4.94e+12. In the year 2003, what is the difference between the Value added (current US$) in High income and Value added (current US$) in Korea (Republic)?
Your response must be concise. 4.78e+12. In the year 2003, what is the difference between the Value added (current US$) of Armenia and Value added (current US$) of Iceland?
Provide a short and direct response. -7.82e+08. In the year 2003, what is the difference between the Value added (current US$) in Armenia and Value added (current US$) in Korea (Republic)?
Your answer should be compact. -1.62e+11. In the year 2003, what is the difference between the Value added (current US$) of Iceland and Value added (current US$) of Korea (Republic)?
Your answer should be very brief. -1.61e+11. In the year 2004, what is the difference between the Value added (current US$) in High income and Value added (current US$) in Armenia?
Make the answer very short. 5.50e+12. In the year 2004, what is the difference between the Value added (current US$) of High income and Value added (current US$) of Iceland?
Keep it short and to the point. 5.50e+12. In the year 2004, what is the difference between the Value added (current US$) of High income and Value added (current US$) of Korea (Republic)?
Provide a short and direct response. 5.31e+12. In the year 2004, what is the difference between the Value added (current US$) of Armenia and Value added (current US$) of Iceland?
Your answer should be very brief. -9.41e+08. In the year 2004, what is the difference between the Value added (current US$) in Armenia and Value added (current US$) in Korea (Republic)?
Ensure brevity in your answer.  -1.96e+11. In the year 2004, what is the difference between the Value added (current US$) of Iceland and Value added (current US$) of Korea (Republic)?
Provide a short and direct response. -1.95e+11. In the year 2005, what is the difference between the Value added (current US$) in High income and Value added (current US$) in Armenia?
Your answer should be very brief. 5.75e+12. In the year 2005, what is the difference between the Value added (current US$) in High income and Value added (current US$) in Iceland?
Give a very brief answer. 5.75e+12. In the year 2005, what is the difference between the Value added (current US$) of High income and Value added (current US$) of Korea (Republic)?
Give a very brief answer. 5.52e+12. In the year 2005, what is the difference between the Value added (current US$) of Armenia and Value added (current US$) of Iceland?
Keep it short and to the point. -8.18e+08. In the year 2005, what is the difference between the Value added (current US$) in Armenia and Value added (current US$) in Korea (Republic)?
Offer a terse response. -2.29e+11. In the year 2005, what is the difference between the Value added (current US$) in Iceland and Value added (current US$) in Korea (Republic)?
Offer a very short reply. -2.28e+11. In the year 2006, what is the difference between the Value added (current US$) in High income and Value added (current US$) in Armenia?
Ensure brevity in your answer.  6.04e+12. In the year 2006, what is the difference between the Value added (current US$) of High income and Value added (current US$) of Iceland?
Your answer should be very brief. 6.04e+12. In the year 2006, what is the difference between the Value added (current US$) in High income and Value added (current US$) in Korea (Republic)?
Your answer should be very brief. 5.79e+12. In the year 2006, what is the difference between the Value added (current US$) of Armenia and Value added (current US$) of Iceland?
Provide a succinct answer. -8.22e+08. In the year 2006, what is the difference between the Value added (current US$) of Armenia and Value added (current US$) of Korea (Republic)?
Make the answer very short. -2.53e+11. In the year 2006, what is the difference between the Value added (current US$) of Iceland and Value added (current US$) of Korea (Republic)?
Keep it short and to the point. -2.52e+11. In the year 2007, what is the difference between the Value added (current US$) in High income and Value added (current US$) in Armenia?
Your answer should be compact. 6.59e+12. In the year 2007, what is the difference between the Value added (current US$) of High income and Value added (current US$) of Iceland?
Make the answer very short. 6.59e+12. In the year 2007, what is the difference between the Value added (current US$) in High income and Value added (current US$) in Korea (Republic)?
Ensure brevity in your answer.  6.30e+12. In the year 2007, what is the difference between the Value added (current US$) in Armenia and Value added (current US$) in Iceland?
Provide a short and direct response. -7.73e+08. In the year 2007, what is the difference between the Value added (current US$) of Armenia and Value added (current US$) of Korea (Republic)?
Give a very brief answer. -2.85e+11. In the year 2007, what is the difference between the Value added (current US$) in Iceland and Value added (current US$) in Korea (Republic)?
Your answer should be compact. -2.84e+11. In the year 2008, what is the difference between the Value added (current US$) of High income and Value added (current US$) of Armenia?
Your answer should be very brief. 6.83e+12. In the year 2008, what is the difference between the Value added (current US$) in High income and Value added (current US$) in Iceland?
Keep it short and to the point. 6.83e+12. In the year 2008, what is the difference between the Value added (current US$) in High income and Value added (current US$) in Korea (Republic)?
Your answer should be very brief. 6.57e+12. In the year 2008, what is the difference between the Value added (current US$) in Armenia and Value added (current US$) in Iceland?
Give a very brief answer. -8.91e+08. In the year 2008, what is the difference between the Value added (current US$) in Armenia and Value added (current US$) in Korea (Republic)?
Your answer should be very brief. -2.58e+11. In the year 2008, what is the difference between the Value added (current US$) in Iceland and Value added (current US$) in Korea (Republic)?
Your answer should be very brief. -2.57e+11. What is the ratio of the Value added (current US$) in Armenia in 2001 to that in 2002?
Keep it short and to the point. 0.92. What is the ratio of the Value added (current US$) of Iceland in 2001 to that in 2002?
Your answer should be compact. 1.02. What is the ratio of the Value added (current US$) of Korea (Republic) in 2001 to that in 2002?
Your answer should be compact. 0.89. What is the ratio of the Value added (current US$) of High income in 2001 to that in 2003?
Offer a terse response. 0.89. What is the ratio of the Value added (current US$) of Armenia in 2001 to that in 2003?
Make the answer very short. 0.77. What is the ratio of the Value added (current US$) in Iceland in 2001 to that in 2003?
Give a very brief answer. 0.89. What is the ratio of the Value added (current US$) in Korea (Republic) in 2001 to that in 2003?
Your response must be concise. 0.81. What is the ratio of the Value added (current US$) of High income in 2001 to that in 2004?
Provide a short and direct response. 0.8. What is the ratio of the Value added (current US$) in Armenia in 2001 to that in 2004?
Provide a succinct answer. 0.68. What is the ratio of the Value added (current US$) of Iceland in 2001 to that in 2004?
Make the answer very short. 0.76. What is the ratio of the Value added (current US$) in Korea (Republic) in 2001 to that in 2004?
Keep it short and to the point. 0.67. What is the ratio of the Value added (current US$) of High income in 2001 to that in 2005?
Make the answer very short. 0.77. What is the ratio of the Value added (current US$) in Armenia in 2001 to that in 2005?
Your answer should be very brief. 0.5. What is the ratio of the Value added (current US$) of Iceland in 2001 to that in 2005?
Your answer should be very brief. 0.73. What is the ratio of the Value added (current US$) in Korea (Republic) in 2001 to that in 2005?
Ensure brevity in your answer.  0.57. What is the ratio of the Value added (current US$) of High income in 2001 to that in 2006?
Make the answer very short. 0.73. What is the ratio of the Value added (current US$) of Armenia in 2001 to that in 2006?
Provide a succinct answer. 0.48. What is the ratio of the Value added (current US$) of Iceland in 2001 to that in 2006?
Ensure brevity in your answer.  0.71. What is the ratio of the Value added (current US$) of Korea (Republic) in 2001 to that in 2006?
Give a very brief answer. 0.52. What is the ratio of the Value added (current US$) in High income in 2001 to that in 2007?
Your answer should be very brief. 0.67. What is the ratio of the Value added (current US$) in Armenia in 2001 to that in 2007?
Your response must be concise. 0.39. What is the ratio of the Value added (current US$) in Iceland in 2001 to that in 2007?
Your response must be concise. 0.66. What is the ratio of the Value added (current US$) of Korea (Republic) in 2001 to that in 2007?
Offer a terse response. 0.46. What is the ratio of the Value added (current US$) in High income in 2001 to that in 2008?
Give a very brief answer. 0.65. What is the ratio of the Value added (current US$) in Armenia in 2001 to that in 2008?
Your response must be concise. 0.32. What is the ratio of the Value added (current US$) in Iceland in 2001 to that in 2008?
Offer a very short reply. 0.56. What is the ratio of the Value added (current US$) of Korea (Republic) in 2001 to that in 2008?
Provide a succinct answer. 0.51. What is the ratio of the Value added (current US$) of High income in 2002 to that in 2003?
Ensure brevity in your answer.  0.9. What is the ratio of the Value added (current US$) in Armenia in 2002 to that in 2003?
Keep it short and to the point. 0.84. What is the ratio of the Value added (current US$) of Iceland in 2002 to that in 2003?
Your response must be concise. 0.87. What is the ratio of the Value added (current US$) of Korea (Republic) in 2002 to that in 2003?
Your answer should be compact. 0.91. What is the ratio of the Value added (current US$) in High income in 2002 to that in 2004?
Keep it short and to the point. 0.81. What is the ratio of the Value added (current US$) of Armenia in 2002 to that in 2004?
Make the answer very short. 0.74. What is the ratio of the Value added (current US$) in Iceland in 2002 to that in 2004?
Your response must be concise. 0.74. What is the ratio of the Value added (current US$) of Korea (Republic) in 2002 to that in 2004?
Your answer should be very brief. 0.75. What is the ratio of the Value added (current US$) of High income in 2002 to that in 2005?
Give a very brief answer. 0.77. What is the ratio of the Value added (current US$) of Armenia in 2002 to that in 2005?
Provide a succinct answer. 0.54. What is the ratio of the Value added (current US$) of Iceland in 2002 to that in 2005?
Your response must be concise. 0.72. What is the ratio of the Value added (current US$) in Korea (Republic) in 2002 to that in 2005?
Give a very brief answer. 0.64. What is the ratio of the Value added (current US$) of High income in 2002 to that in 2006?
Ensure brevity in your answer.  0.73. What is the ratio of the Value added (current US$) of Armenia in 2002 to that in 2006?
Ensure brevity in your answer.  0.52. What is the ratio of the Value added (current US$) in Iceland in 2002 to that in 2006?
Give a very brief answer. 0.7. What is the ratio of the Value added (current US$) of Korea (Republic) in 2002 to that in 2006?
Provide a succinct answer. 0.58. What is the ratio of the Value added (current US$) in High income in 2002 to that in 2007?
Give a very brief answer. 0.67. What is the ratio of the Value added (current US$) of Armenia in 2002 to that in 2007?
Your answer should be very brief. 0.42. What is the ratio of the Value added (current US$) in Iceland in 2002 to that in 2007?
Your answer should be very brief. 0.65. What is the ratio of the Value added (current US$) of Korea (Republic) in 2002 to that in 2007?
Provide a short and direct response. 0.52. What is the ratio of the Value added (current US$) of High income in 2002 to that in 2008?
Ensure brevity in your answer.  0.65. What is the ratio of the Value added (current US$) of Armenia in 2002 to that in 2008?
Make the answer very short. 0.35. What is the ratio of the Value added (current US$) in Iceland in 2002 to that in 2008?
Your answer should be compact. 0.55. What is the ratio of the Value added (current US$) of Korea (Republic) in 2002 to that in 2008?
Provide a short and direct response. 0.57. What is the ratio of the Value added (current US$) in High income in 2003 to that in 2004?
Your answer should be compact. 0.9. What is the ratio of the Value added (current US$) of Armenia in 2003 to that in 2004?
Provide a short and direct response. 0.89. What is the ratio of the Value added (current US$) of Iceland in 2003 to that in 2004?
Provide a short and direct response. 0.85. What is the ratio of the Value added (current US$) of Korea (Republic) in 2003 to that in 2004?
Your answer should be very brief. 0.83. What is the ratio of the Value added (current US$) in High income in 2003 to that in 2005?
Make the answer very short. 0.86. What is the ratio of the Value added (current US$) of Armenia in 2003 to that in 2005?
Your answer should be very brief. 0.65. What is the ratio of the Value added (current US$) of Iceland in 2003 to that in 2005?
Keep it short and to the point. 0.82. What is the ratio of the Value added (current US$) in Korea (Republic) in 2003 to that in 2005?
Offer a terse response. 0.71. What is the ratio of the Value added (current US$) in High income in 2003 to that in 2006?
Ensure brevity in your answer.  0.82. What is the ratio of the Value added (current US$) in Armenia in 2003 to that in 2006?
Offer a terse response. 0.62. What is the ratio of the Value added (current US$) of Iceland in 2003 to that in 2006?
Offer a terse response. 0.8. What is the ratio of the Value added (current US$) of Korea (Republic) in 2003 to that in 2006?
Make the answer very short. 0.64. What is the ratio of the Value added (current US$) in High income in 2003 to that in 2007?
Ensure brevity in your answer.  0.75. What is the ratio of the Value added (current US$) of Armenia in 2003 to that in 2007?
Make the answer very short. 0.5. What is the ratio of the Value added (current US$) of Iceland in 2003 to that in 2007?
Offer a terse response. 0.74. What is the ratio of the Value added (current US$) of Korea (Republic) in 2003 to that in 2007?
Your answer should be compact. 0.57. What is the ratio of the Value added (current US$) of High income in 2003 to that in 2008?
Make the answer very short. 0.72. What is the ratio of the Value added (current US$) of Armenia in 2003 to that in 2008?
Provide a succinct answer. 0.42. What is the ratio of the Value added (current US$) of Iceland in 2003 to that in 2008?
Your answer should be compact. 0.63. What is the ratio of the Value added (current US$) of Korea (Republic) in 2003 to that in 2008?
Offer a terse response. 0.63. What is the ratio of the Value added (current US$) in High income in 2004 to that in 2005?
Make the answer very short. 0.96. What is the ratio of the Value added (current US$) of Armenia in 2004 to that in 2005?
Offer a terse response. 0.73. What is the ratio of the Value added (current US$) of Iceland in 2004 to that in 2005?
Provide a succinct answer. 0.96. What is the ratio of the Value added (current US$) of Korea (Republic) in 2004 to that in 2005?
Provide a succinct answer. 0.86. What is the ratio of the Value added (current US$) in High income in 2004 to that in 2006?
Give a very brief answer. 0.91. What is the ratio of the Value added (current US$) of Armenia in 2004 to that in 2006?
Provide a short and direct response. 0.7. What is the ratio of the Value added (current US$) of Iceland in 2004 to that in 2006?
Ensure brevity in your answer.  0.94. What is the ratio of the Value added (current US$) in Korea (Republic) in 2004 to that in 2006?
Give a very brief answer. 0.78. What is the ratio of the Value added (current US$) in High income in 2004 to that in 2007?
Provide a short and direct response. 0.84. What is the ratio of the Value added (current US$) in Armenia in 2004 to that in 2007?
Keep it short and to the point. 0.56. What is the ratio of the Value added (current US$) in Iceland in 2004 to that in 2007?
Provide a short and direct response. 0.87. What is the ratio of the Value added (current US$) in Korea (Republic) in 2004 to that in 2007?
Provide a succinct answer. 0.69. What is the ratio of the Value added (current US$) in High income in 2004 to that in 2008?
Ensure brevity in your answer.  0.81. What is the ratio of the Value added (current US$) of Armenia in 2004 to that in 2008?
Provide a succinct answer. 0.47. What is the ratio of the Value added (current US$) in Iceland in 2004 to that in 2008?
Offer a terse response. 0.74. What is the ratio of the Value added (current US$) of Korea (Republic) in 2004 to that in 2008?
Provide a succinct answer. 0.76. What is the ratio of the Value added (current US$) in High income in 2005 to that in 2006?
Your answer should be very brief. 0.95. What is the ratio of the Value added (current US$) of Armenia in 2005 to that in 2006?
Provide a succinct answer. 0.96. What is the ratio of the Value added (current US$) in Iceland in 2005 to that in 2006?
Ensure brevity in your answer.  0.98. What is the ratio of the Value added (current US$) of Korea (Republic) in 2005 to that in 2006?
Keep it short and to the point. 0.9. What is the ratio of the Value added (current US$) of High income in 2005 to that in 2007?
Your response must be concise. 0.87. What is the ratio of the Value added (current US$) of Armenia in 2005 to that in 2007?
Provide a succinct answer. 0.77. What is the ratio of the Value added (current US$) of Iceland in 2005 to that in 2007?
Offer a terse response. 0.91. What is the ratio of the Value added (current US$) of Korea (Republic) in 2005 to that in 2007?
Keep it short and to the point. 0.8. What is the ratio of the Value added (current US$) in High income in 2005 to that in 2008?
Provide a short and direct response. 0.84. What is the ratio of the Value added (current US$) of Armenia in 2005 to that in 2008?
Keep it short and to the point. 0.64. What is the ratio of the Value added (current US$) in Iceland in 2005 to that in 2008?
Ensure brevity in your answer.  0.77. What is the ratio of the Value added (current US$) of Korea (Republic) in 2005 to that in 2008?
Your answer should be compact. 0.89. What is the ratio of the Value added (current US$) in High income in 2006 to that in 2007?
Ensure brevity in your answer.  0.92. What is the ratio of the Value added (current US$) in Armenia in 2006 to that in 2007?
Give a very brief answer. 0.8. What is the ratio of the Value added (current US$) in Iceland in 2006 to that in 2007?
Give a very brief answer. 0.93. What is the ratio of the Value added (current US$) of Korea (Republic) in 2006 to that in 2007?
Your answer should be compact. 0.89. What is the ratio of the Value added (current US$) of High income in 2006 to that in 2008?
Your answer should be very brief. 0.88. What is the ratio of the Value added (current US$) of Armenia in 2006 to that in 2008?
Keep it short and to the point. 0.67. What is the ratio of the Value added (current US$) of Iceland in 2006 to that in 2008?
Your response must be concise. 0.79. What is the ratio of the Value added (current US$) of Korea (Republic) in 2006 to that in 2008?
Your answer should be very brief. 0.98. What is the ratio of the Value added (current US$) in High income in 2007 to that in 2008?
Give a very brief answer. 0.96. What is the ratio of the Value added (current US$) in Armenia in 2007 to that in 2008?
Your answer should be compact. 0.84. What is the ratio of the Value added (current US$) of Iceland in 2007 to that in 2008?
Your answer should be compact. 0.85. What is the ratio of the Value added (current US$) in Korea (Republic) in 2007 to that in 2008?
Provide a succinct answer. 1.11. What is the difference between the highest and the second highest Value added (current US$) of High income?
Make the answer very short. 2.43e+11. What is the difference between the highest and the second highest Value added (current US$) in Armenia?
Your response must be concise. 1.68e+08. What is the difference between the highest and the second highest Value added (current US$) in Iceland?
Ensure brevity in your answer.  2.86e+08. What is the difference between the highest and the second highest Value added (current US$) in Korea (Republic)?
Your answer should be compact. 2.73e+1. What is the difference between the highest and the lowest Value added (current US$) of High income?
Keep it short and to the point. 2.42e+12. What is the difference between the highest and the lowest Value added (current US$) in Armenia?
Provide a short and direct response. 6.99e+08. What is the difference between the highest and the lowest Value added (current US$) of Iceland?
Provide a short and direct response. 8.62e+08. What is the difference between the highest and the lowest Value added (current US$) in Korea (Republic)?
Offer a very short reply. 1.54e+11. 